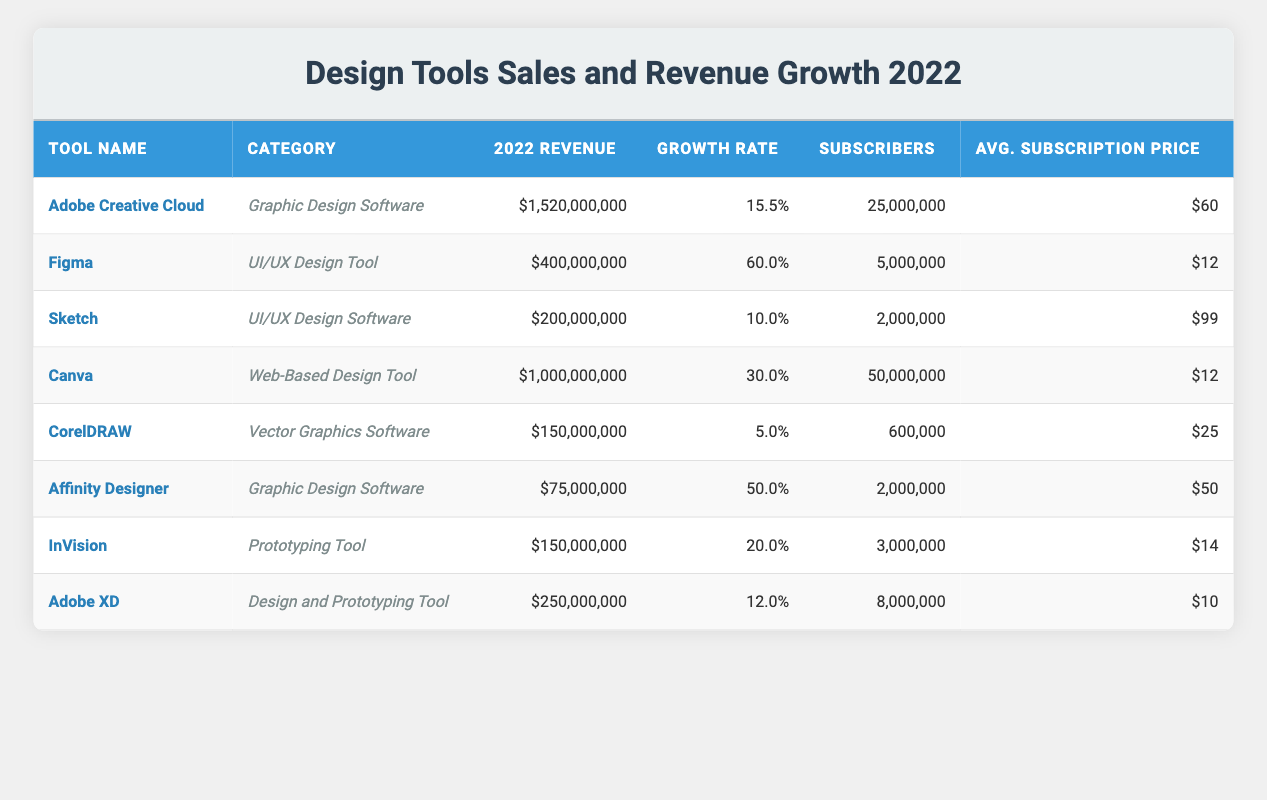What is the total revenue generated by Adobe Creative Cloud in 2022? According to the table, the revenue for Adobe Creative Cloud in 2022 is listed as $1,520,000,000.
Answer: $1,520,000,000 Which design tool had the highest growth rate in 2022? The table shows that Figma had the highest growth rate at 60.0%.
Answer: Figma What is the average subscription price for Sketch? From the table, the average subscription price for Sketch is $99.
Answer: $99 What was the total revenue generated by all design tools in 2022? To find the total revenue, I need to sum the revenues from each tool: 1,520,000,000 + 400,000,000 + 200,000,000 + 1,000,000,000 + 150,000,000 + 75,000,000 + 150,000,000 + 250,000,000 = 3,745,000,000.
Answer: $3,745,000,000 Did Adobe XD generate more revenue than InVision in 2022? The table indicates that Adobe XD's revenue is $250,000,000 while InVision's revenue is $150,000,000, so yes, Adobe XD generated more revenue.
Answer: Yes Which tool has the most subscribers, and how many are there? The table shows that Canva has the most subscribers with a total of 50,000,000.
Answer: Canva; 50,000,000 What is the difference in revenue between Canva and Affinity Designer? To find this, subtract the revenue of Affinity Designer ($75,000,000) from Canva's revenue ($1,000,000,000): 1,000,000,000 - 75,000,000 = 925,000,000.
Answer: $925,000,000 Which category of design tools has the lowest average subscription price? The average subscription prices are as follows: Figma ($12), Canva ($12), and CorelDRAW ($25). Both Figma and Canva have the lowest average subscription price of $12.
Answer: Figma and Canva; $12 Is there a design tool with a growth rate higher than 30%? Looking at the growth rates listed in the table, Figma (60.0%), Canva (30.0%), and Affinity Designer (50.0%) all exceed 30%, meaning there are indeed tools with a higher growth rate.
Answer: Yes What percentage of the overall subscribers do Adobe Creative Cloud's subscribers represent? First, I calculate the total number of subscribers: 25,000,000 + 5,000,000 + 2,000,000 + 50,000,000 + 600,000 + 2,000,000 + 3,000,000 + 8,000,000 = 95,600,000. Then, Adobe Creative Cloud's subscribers make up: (25,000,000 / 95,600,000) * 100 = 26.19%.
Answer: 26.19% 